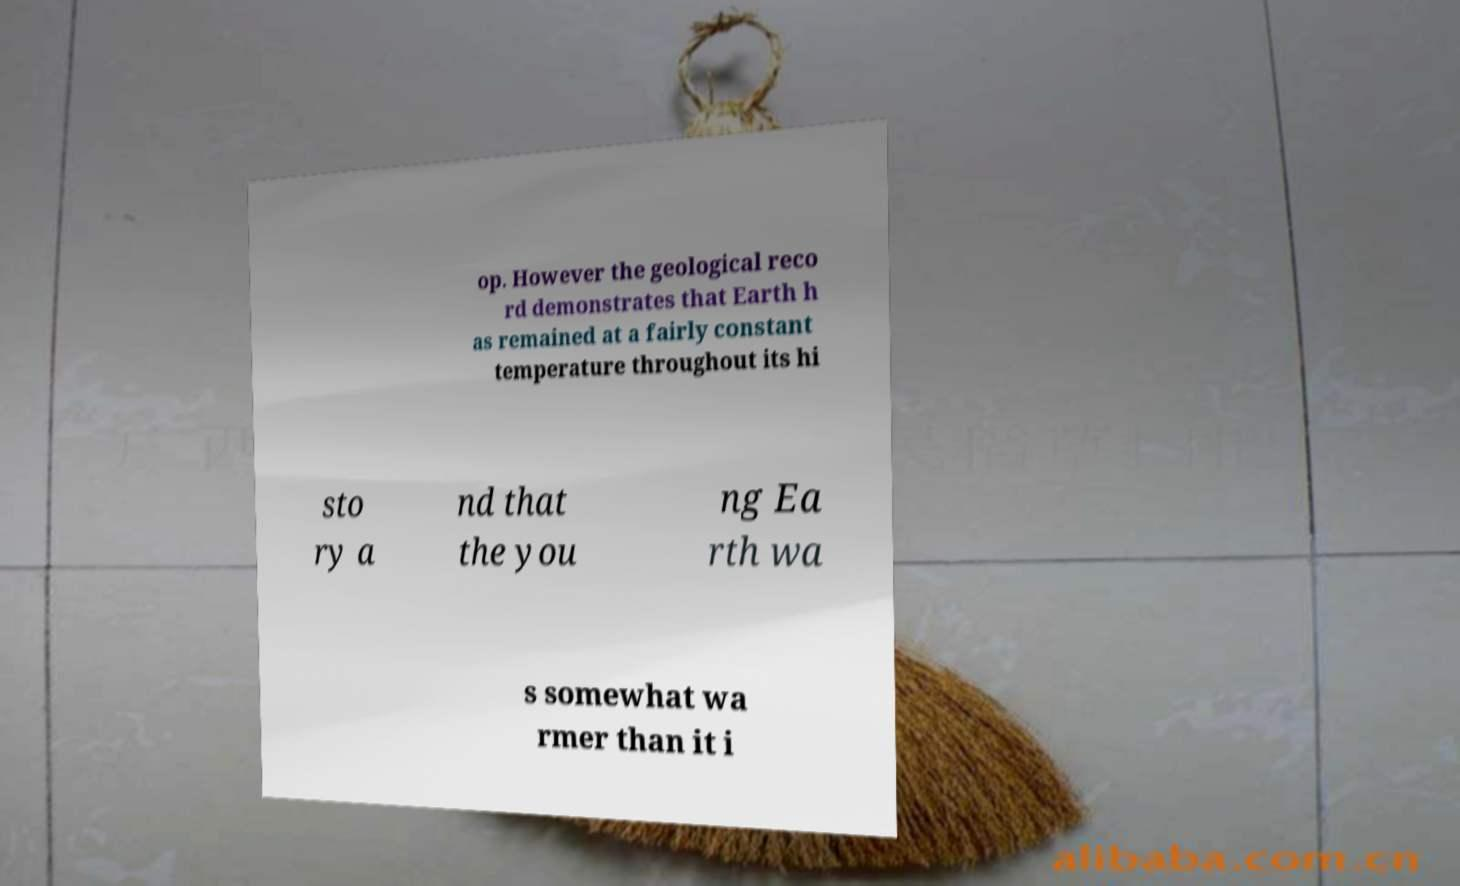What messages or text are displayed in this image? I need them in a readable, typed format. op. However the geological reco rd demonstrates that Earth h as remained at a fairly constant temperature throughout its hi sto ry a nd that the you ng Ea rth wa s somewhat wa rmer than it i 